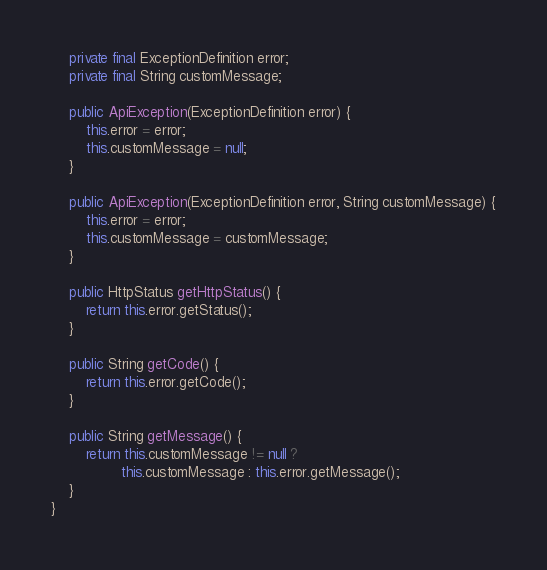Convert code to text. <code><loc_0><loc_0><loc_500><loc_500><_Java_>
    private final ExceptionDefinition error;
    private final String customMessage;

    public ApiException(ExceptionDefinition error) {
        this.error = error;
        this.customMessage = null;
    }

    public ApiException(ExceptionDefinition error, String customMessage) {
        this.error = error;
        this.customMessage = customMessage;
    }

    public HttpStatus getHttpStatus() {
        return this.error.getStatus();
    }

    public String getCode() {
        return this.error.getCode();
    }

    public String getMessage() {
        return this.customMessage != null ?
                this.customMessage : this.error.getMessage();
    }
}
</code> 